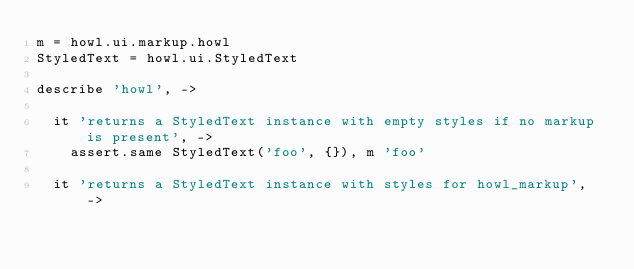<code> <loc_0><loc_0><loc_500><loc_500><_MoonScript_>m = howl.ui.markup.howl
StyledText = howl.ui.StyledText

describe 'howl', ->

  it 'returns a StyledText instance with empty styles if no markup is present', ->
    assert.same StyledText('foo', {}), m 'foo'

  it 'returns a StyledText instance with styles for howl_markup', -></code> 